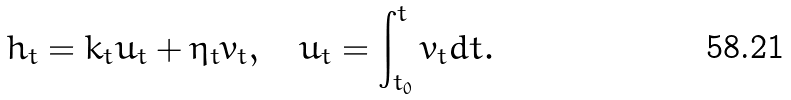<formula> <loc_0><loc_0><loc_500><loc_500>h _ { t } = k _ { t } u _ { t } + \eta _ { t } v _ { t } , \quad u _ { t } = \int ^ { t } _ { t _ { 0 } } v _ { t } d t .</formula> 